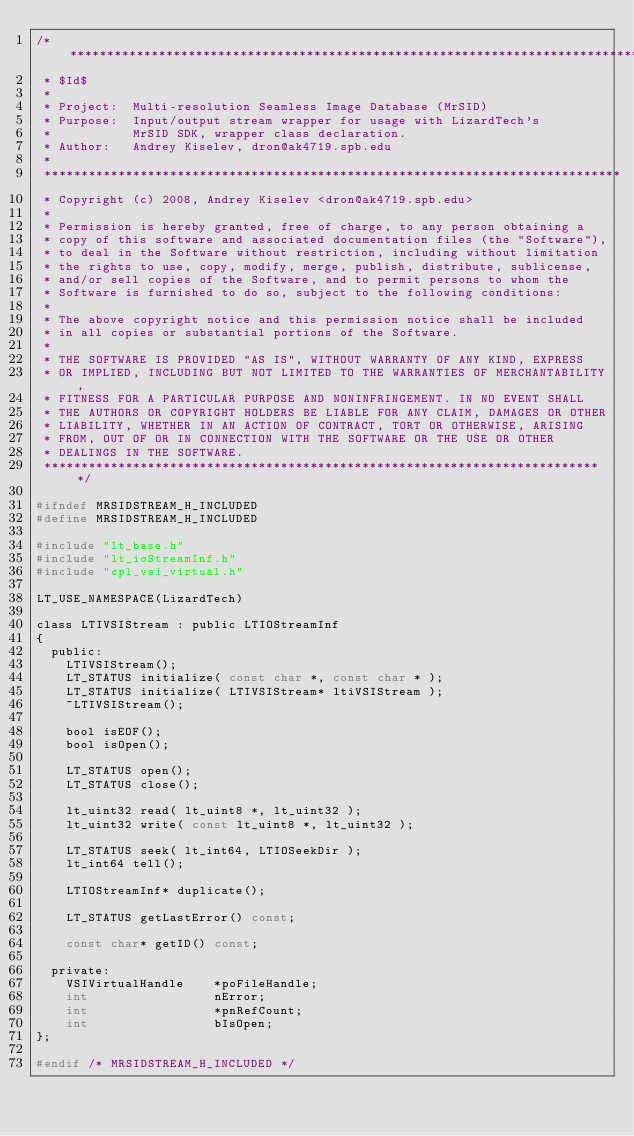Convert code to text. <code><loc_0><loc_0><loc_500><loc_500><_C_>/******************************************************************************
 * $Id$
 *
 * Project:  Multi-resolution Seamless Image Database (MrSID)
 * Purpose:  Input/output stream wrapper for usage with LizardTech's
 *           MrSID SDK, wrapper class declaration.
 * Author:   Andrey Kiselev, dron@ak4719.spb.edu
 *
 ******************************************************************************
 * Copyright (c) 2008, Andrey Kiselev <dron@ak4719.spb.edu>
 *
 * Permission is hereby granted, free of charge, to any person obtaining a
 * copy of this software and associated documentation files (the "Software"),
 * to deal in the Software without restriction, including without limitation
 * the rights to use, copy, modify, merge, publish, distribute, sublicense,
 * and/or sell copies of the Software, and to permit persons to whom the
 * Software is furnished to do so, subject to the following conditions:
 *
 * The above copyright notice and this permission notice shall be included
 * in all copies or substantial portions of the Software.
 *
 * THE SOFTWARE IS PROVIDED "AS IS", WITHOUT WARRANTY OF ANY KIND, EXPRESS
 * OR IMPLIED, INCLUDING BUT NOT LIMITED TO THE WARRANTIES OF MERCHANTABILITY,
 * FITNESS FOR A PARTICULAR PURPOSE AND NONINFRINGEMENT. IN NO EVENT SHALL
 * THE AUTHORS OR COPYRIGHT HOLDERS BE LIABLE FOR ANY CLAIM, DAMAGES OR OTHER
 * LIABILITY, WHETHER IN AN ACTION OF CONTRACT, TORT OR OTHERWISE, ARISING
 * FROM, OUT OF OR IN CONNECTION WITH THE SOFTWARE OR THE USE OR OTHER
 * DEALINGS IN THE SOFTWARE.
 ****************************************************************************/

#ifndef MRSIDSTREAM_H_INCLUDED
#define MRSIDSTREAM_H_INCLUDED

#include "lt_base.h"
#include "lt_ioStreamInf.h"
#include "cpl_vsi_virtual.h"

LT_USE_NAMESPACE(LizardTech)

class LTIVSIStream : public LTIOStreamInf
{
  public:
    LTIVSIStream();
    LT_STATUS initialize( const char *, const char * );
    LT_STATUS initialize( LTIVSIStream* ltiVSIStream );
    ~LTIVSIStream();

    bool isEOF();
    bool isOpen();
    
    LT_STATUS open();
    LT_STATUS close();
    
    lt_uint32 read( lt_uint8 *, lt_uint32 );
    lt_uint32 write( const lt_uint8 *, lt_uint32 );
    
    LT_STATUS seek( lt_int64, LTIOSeekDir );
    lt_int64 tell();
    
    LTIOStreamInf* duplicate();
    
    LT_STATUS getLastError() const;
    
    const char* getID() const;

  private:
    VSIVirtualHandle    *poFileHandle;
    int                 nError;
    int                 *pnRefCount;
    int                 bIsOpen;
};

#endif /* MRSIDSTREAM_H_INCLUDED */

</code> 